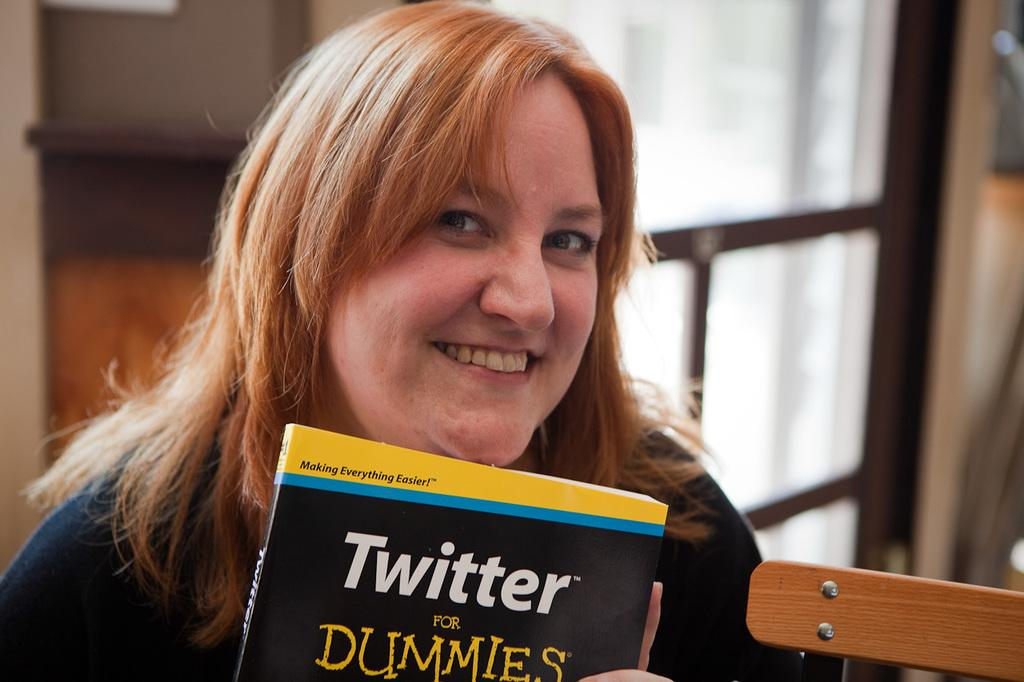What is the person in the image holding? The person is holding a book in the image. What can be seen on the right side of the image? There is an object on the right side of the image. What is visible in the background of the image? There is a wall and other unspecified objects in the background of the image. How many pigs are visible in the image? There are no pigs present in the image. What type of copy is being made in the image? There is no copying or duplication activity depicted in the image. 